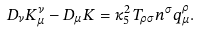Convert formula to latex. <formula><loc_0><loc_0><loc_500><loc_500>D _ { \nu } K ^ { \nu } _ { \mu } - D _ { \mu } K = \kappa _ { 5 } ^ { 2 } \, T _ { \rho \sigma } n ^ { \sigma } q _ { \mu } ^ { \rho } .</formula> 